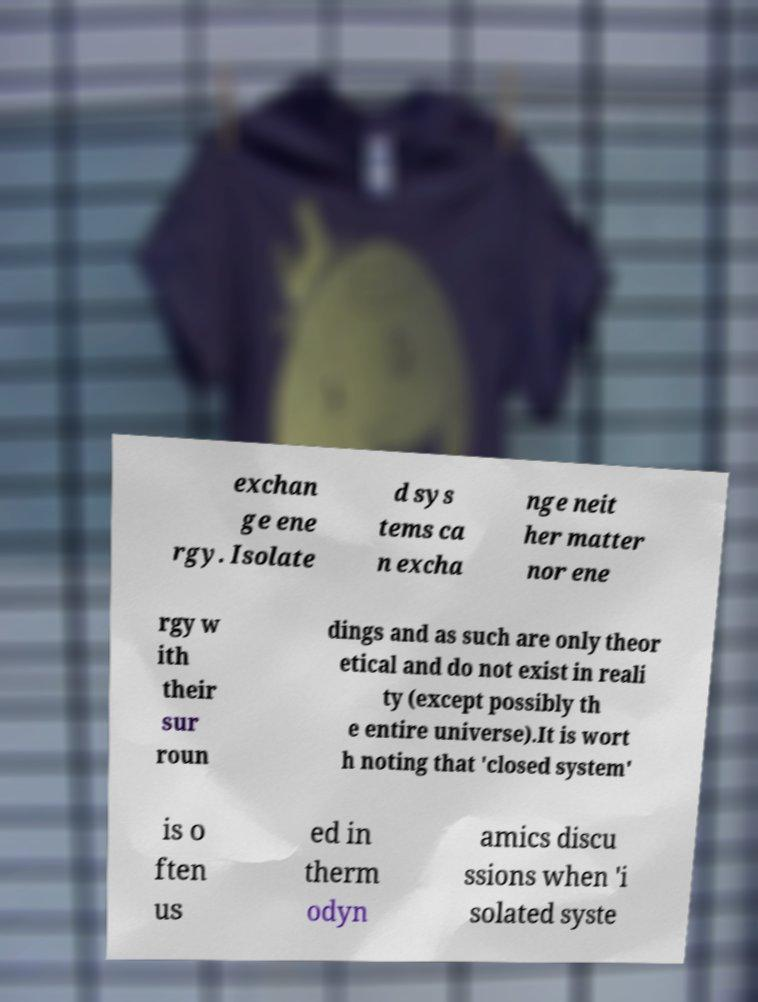Could you extract and type out the text from this image? exchan ge ene rgy. Isolate d sys tems ca n excha nge neit her matter nor ene rgy w ith their sur roun dings and as such are only theor etical and do not exist in reali ty (except possibly th e entire universe).It is wort h noting that 'closed system' is o ften us ed in therm odyn amics discu ssions when 'i solated syste 